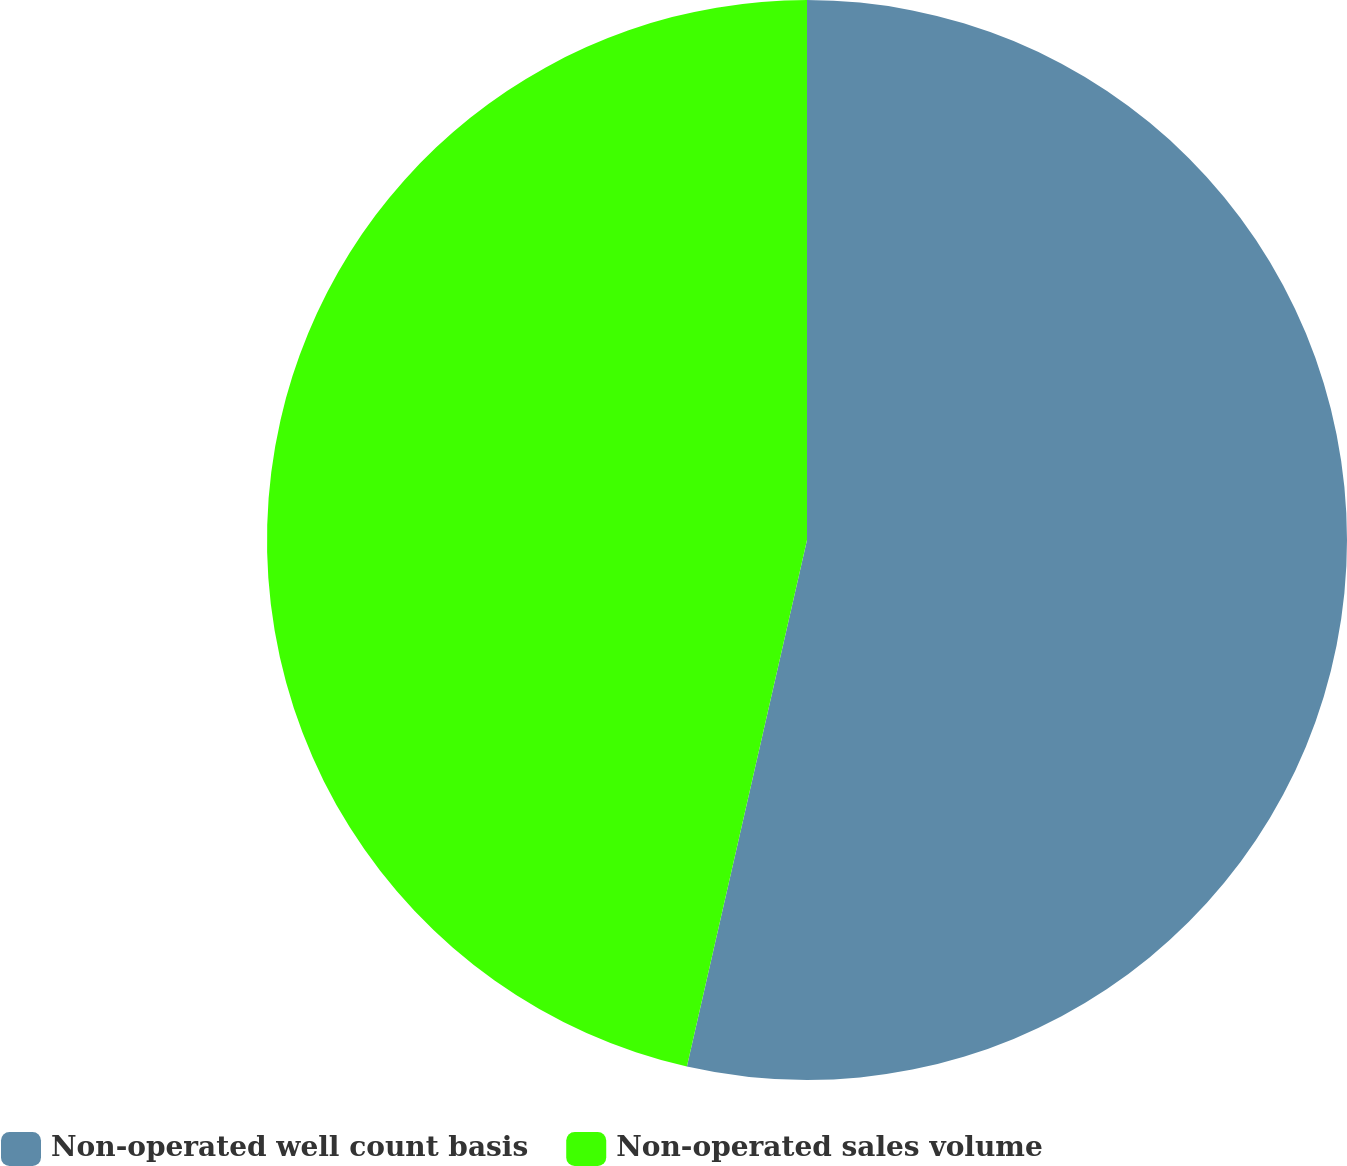<chart> <loc_0><loc_0><loc_500><loc_500><pie_chart><fcel>Non-operated well count basis<fcel>Non-operated sales volume<nl><fcel>53.57%<fcel>46.43%<nl></chart> 